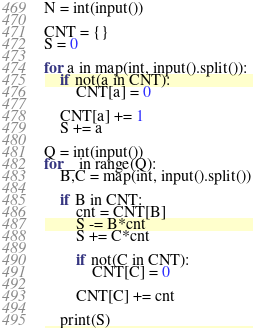<code> <loc_0><loc_0><loc_500><loc_500><_Python_>N = int(input())

CNT = {}
S = 0

for a in map(int, input().split()):
    if not(a in CNT):
        CNT[a] = 0

    CNT[a] += 1
    S += a

Q = int(input())
for _ in range(Q):
    B,C = map(int, input().split())

    if B in CNT:
        cnt = CNT[B]
        S -= B*cnt
        S += C*cnt
        
        if not(C in CNT):
            CNT[C] = 0

        CNT[C] += cnt
        
    print(S)

</code> 